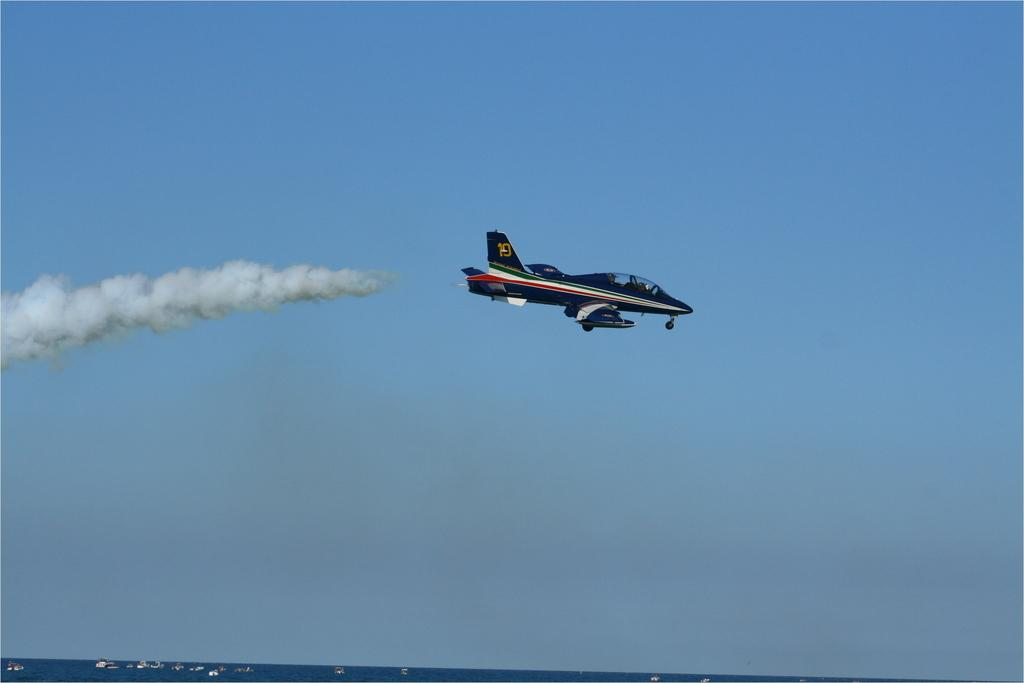Provide a one-sentence caption for the provided image. A jet plane has the number 10 on it's tail. 